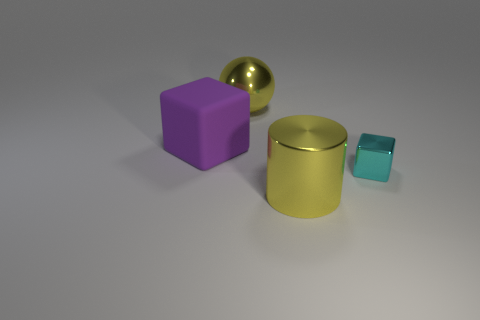Add 2 brown metallic cylinders. How many objects exist? 6 Subtract all red cubes. Subtract all red balls. How many cubes are left? 2 Subtract all spheres. How many objects are left? 3 Subtract all large yellow metallic spheres. Subtract all big yellow metal cylinders. How many objects are left? 2 Add 4 large yellow cylinders. How many large yellow cylinders are left? 5 Add 2 large blue cylinders. How many large blue cylinders exist? 2 Subtract 0 brown cylinders. How many objects are left? 4 